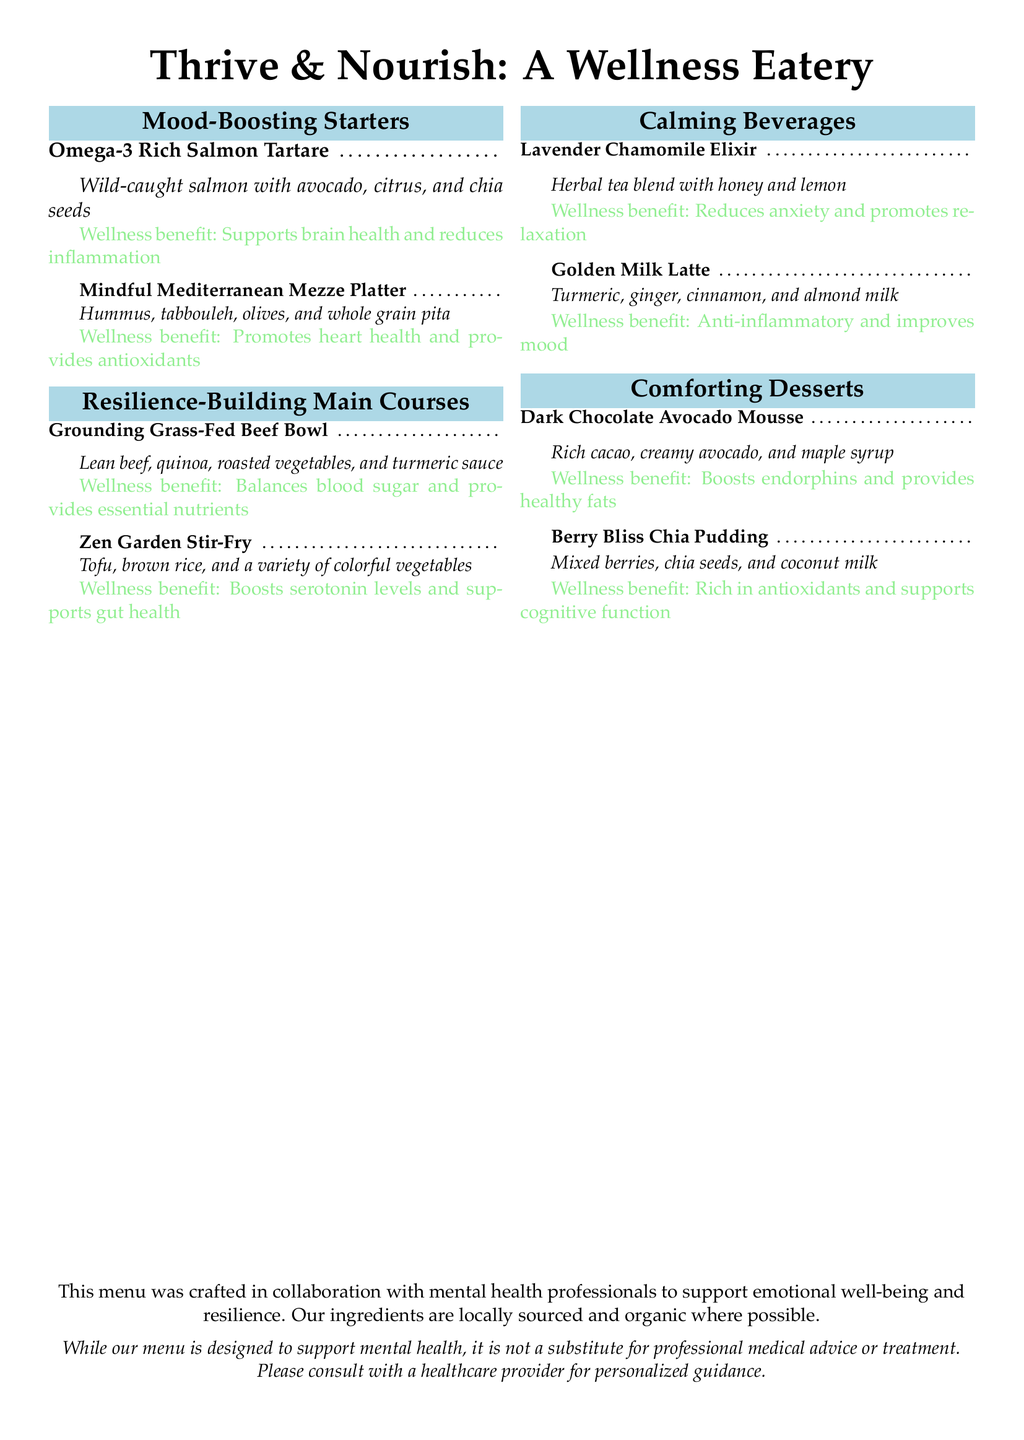What is the name of the wellness eatery? The name of the wellness eatery is presented at the top of the document.
Answer: Thrive & Nourish: A Wellness Eatery How many starters are listed on the menu? The menu lists two sections of starters, and the count of menu items can be found under "Mood-Boosting Starters."
Answer: 2 What main ingredient is in the Zen Garden Stir-Fry? The Zen Garden Stir-Fry includes tofu as its main ingredient.
Answer: Tofu Which dessert contains healthy fats? The dessert mentioned specifically for its healthy fats is listed.
Answer: Dark Chocolate Avocado Mousse What benefit does the Lavender Chamomile Elixir provide? The document provides a wellness benefit for the beverage, which can be summarized.
Answer: Reduces anxiety and promotes relaxation What is the color theme used in the document? The document features a color scheme with specific colors mentioned in the code.
Answer: Soft blue and soft green Which item is noted for supporting gut health? The item with specific reference to gut health is included in the main courses section.
Answer: Zen Garden Stir-Fry What is the primary focus of the menu? The document explicitly states the purpose of the menu at the end.
Answer: Support emotional well-being and resilience How are the ingredients described in terms of sourcing? The sourcing of the ingredients is mentioned in a specific phrase within the document.
Answer: Locally sourced and organic where possible 